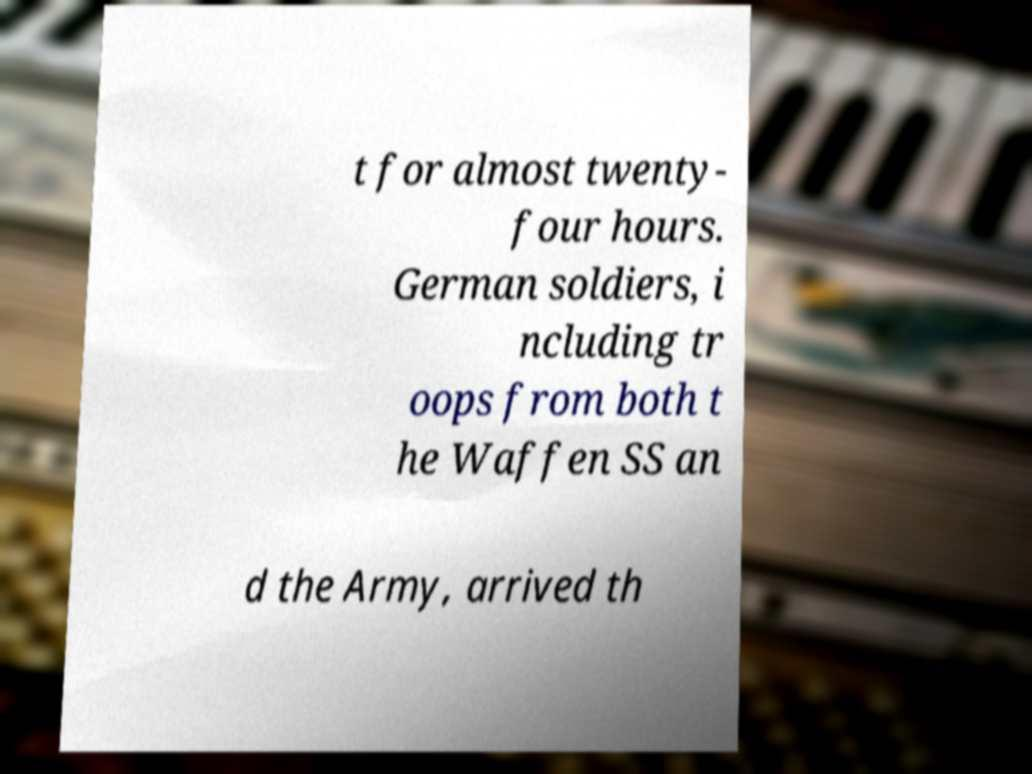Could you extract and type out the text from this image? t for almost twenty- four hours. German soldiers, i ncluding tr oops from both t he Waffen SS an d the Army, arrived th 